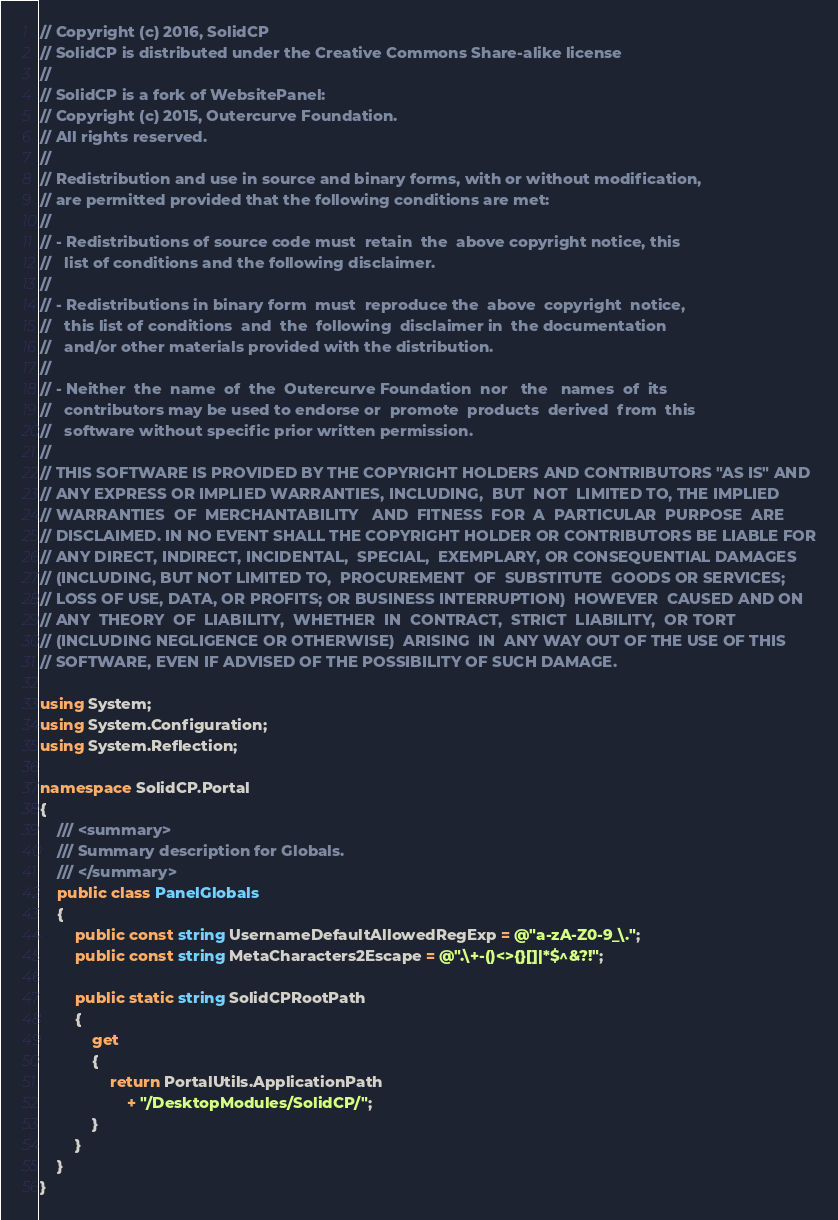<code> <loc_0><loc_0><loc_500><loc_500><_C#_>// Copyright (c) 2016, SolidCP
// SolidCP is distributed under the Creative Commons Share-alike license
// 
// SolidCP is a fork of WebsitePanel:
// Copyright (c) 2015, Outercurve Foundation.
// All rights reserved.
//
// Redistribution and use in source and binary forms, with or without modification,
// are permitted provided that the following conditions are met:
//
// - Redistributions of source code must  retain  the  above copyright notice, this
//   list of conditions and the following disclaimer.
//
// - Redistributions in binary form  must  reproduce the  above  copyright  notice,
//   this list of conditions  and  the  following  disclaimer in  the documentation
//   and/or other materials provided with the distribution.
//
// - Neither  the  name  of  the  Outercurve Foundation  nor   the   names  of  its
//   contributors may be used to endorse or  promote  products  derived  from  this
//   software without specific prior written permission.
//
// THIS SOFTWARE IS PROVIDED BY THE COPYRIGHT HOLDERS AND CONTRIBUTORS "AS IS" AND
// ANY EXPRESS OR IMPLIED WARRANTIES, INCLUDING,  BUT  NOT  LIMITED TO, THE IMPLIED
// WARRANTIES  OF  MERCHANTABILITY   AND  FITNESS  FOR  A  PARTICULAR  PURPOSE  ARE
// DISCLAIMED. IN NO EVENT SHALL THE COPYRIGHT HOLDER OR CONTRIBUTORS BE LIABLE FOR
// ANY DIRECT, INDIRECT, INCIDENTAL,  SPECIAL,  EXEMPLARY, OR CONSEQUENTIAL DAMAGES
// (INCLUDING, BUT NOT LIMITED TO,  PROCUREMENT  OF  SUBSTITUTE  GOODS OR SERVICES;
// LOSS OF USE, DATA, OR PROFITS; OR BUSINESS INTERRUPTION)  HOWEVER  CAUSED AND ON
// ANY  THEORY  OF  LIABILITY,  WHETHER  IN  CONTRACT,  STRICT  LIABILITY,  OR TORT
// (INCLUDING NEGLIGENCE OR OTHERWISE)  ARISING  IN  ANY WAY OUT OF THE USE OF THIS
// SOFTWARE, EVEN IF ADVISED OF THE POSSIBILITY OF SUCH DAMAGE.

using System;
using System.Configuration;
using System.Reflection;

namespace SolidCP.Portal
{
    /// <summary>
    /// Summary description for Globals.
    /// </summary>
    public class PanelGlobals
    {
        public const string UsernameDefaultAllowedRegExp = @"a-zA-Z0-9_\.";
		public const string MetaCharacters2Escape = @".\+-()<>{}[]|*$^&?!";

        public static string SolidCPRootPath
        {
            get
            {
				return PortalUtils.ApplicationPath
					+ "/DesktopModules/SolidCP/";
            }
        }
    }
}
</code> 